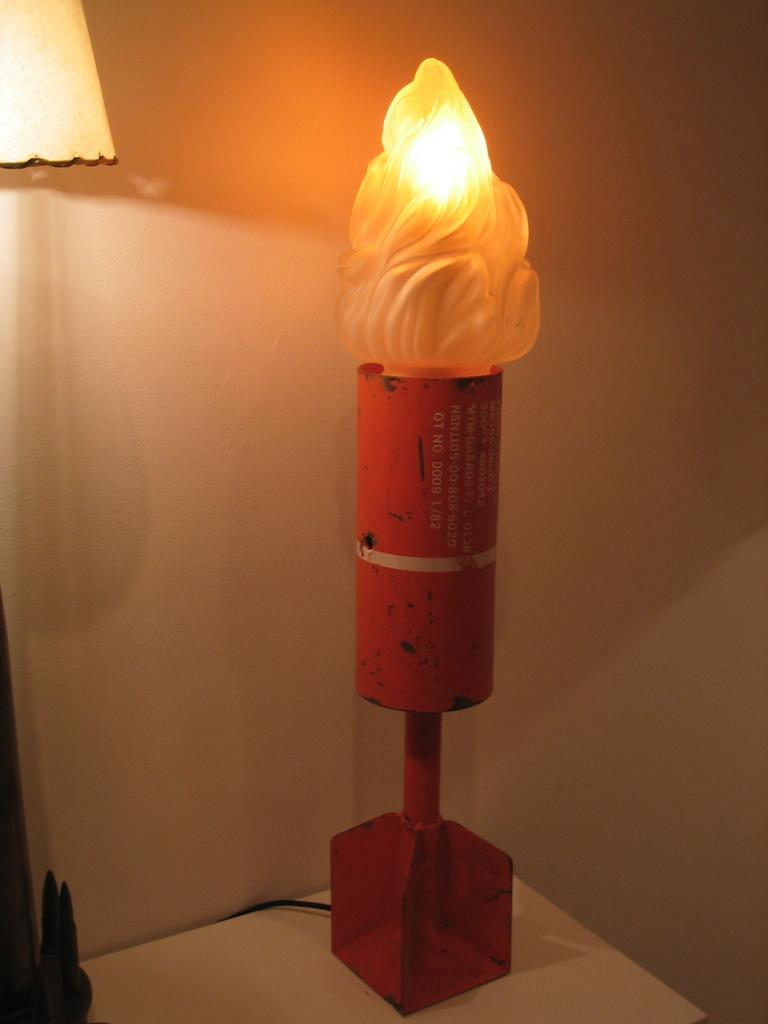What object can be seen in the image? There is a lamp in the image. Where is the lamp located? The lamp is placed on a table. What can be seen in the background of the image? There is a wall in the background of the image. What type of food is being prepared on the van in the image? There is no van or food preparation present in the image; it only features a lamp on a table with a wall in the background. 